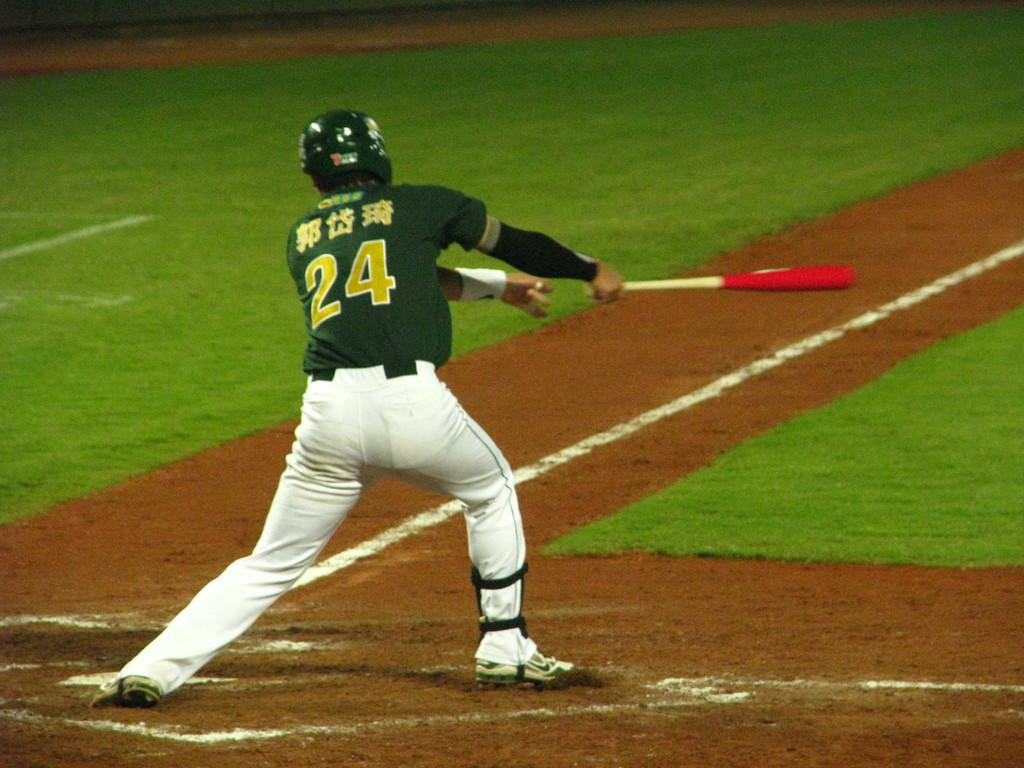What is the man in the image doing? The man is playing baseball in the image. What color is the man's t-shirt? The man is wearing a green t-shirt. What color are the man's trousers? The man is wearing white trousers. What type of headwear is the man wearing? The man is wearing a black cap. What is the man's sister doing in the image? There is no mention of a sister in the image, so we cannot answer this question. 